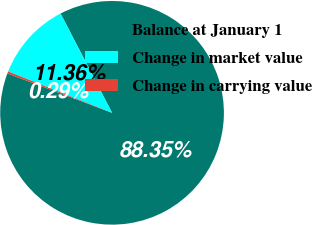Convert chart to OTSL. <chart><loc_0><loc_0><loc_500><loc_500><pie_chart><fcel>Balance at January 1<fcel>Change in market value<fcel>Change in carrying value<nl><fcel>88.35%<fcel>11.36%<fcel>0.29%<nl></chart> 